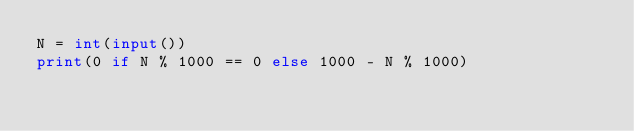Convert code to text. <code><loc_0><loc_0><loc_500><loc_500><_Python_>N = int(input())
print(0 if N % 1000 == 0 else 1000 - N % 1000)</code> 